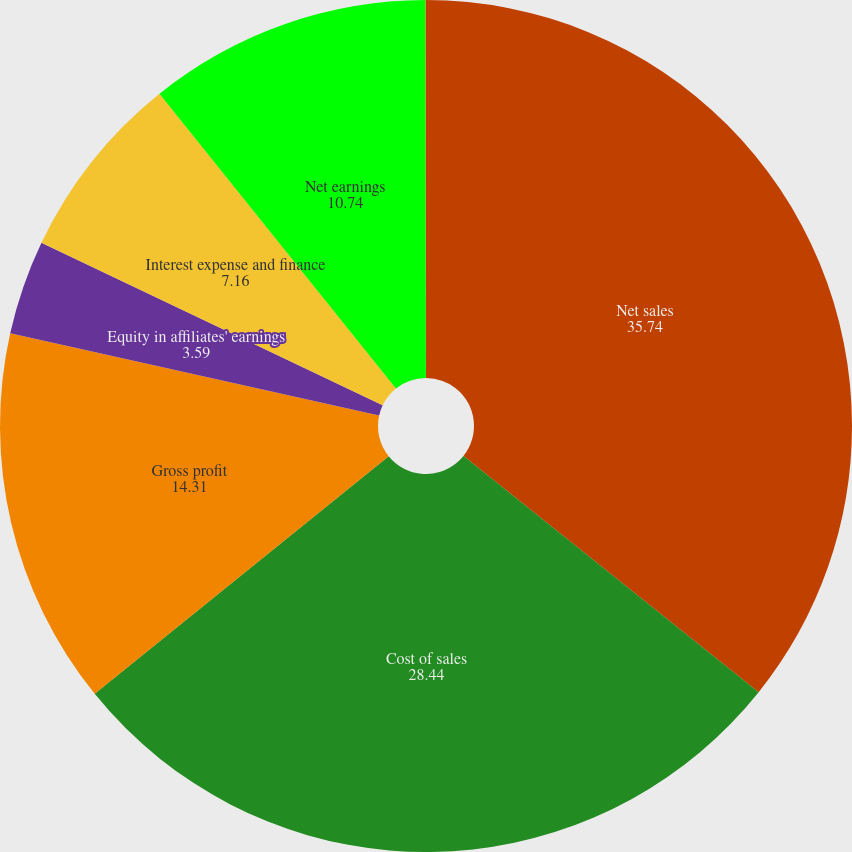<chart> <loc_0><loc_0><loc_500><loc_500><pie_chart><fcel>Net sales<fcel>Cost of sales<fcel>Gross profit<fcel>Equity in affiliates' earnings<fcel>Interest expense and finance<fcel>Net earnings<fcel>Earnings per share - diluted<nl><fcel>35.74%<fcel>28.44%<fcel>14.31%<fcel>3.59%<fcel>7.16%<fcel>10.74%<fcel>0.02%<nl></chart> 